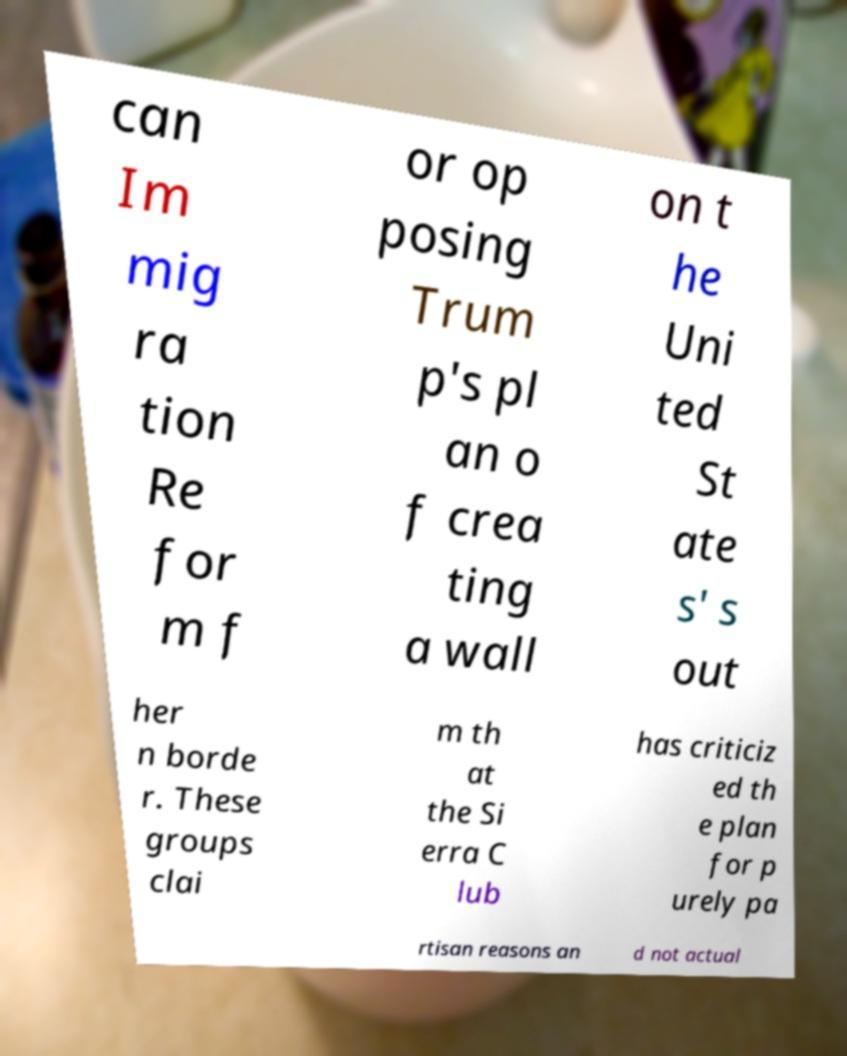I need the written content from this picture converted into text. Can you do that? can Im mig ra tion Re for m f or op posing Trum p's pl an o f crea ting a wall on t he Uni ted St ate s' s out her n borde r. These groups clai m th at the Si erra C lub has criticiz ed th e plan for p urely pa rtisan reasons an d not actual 